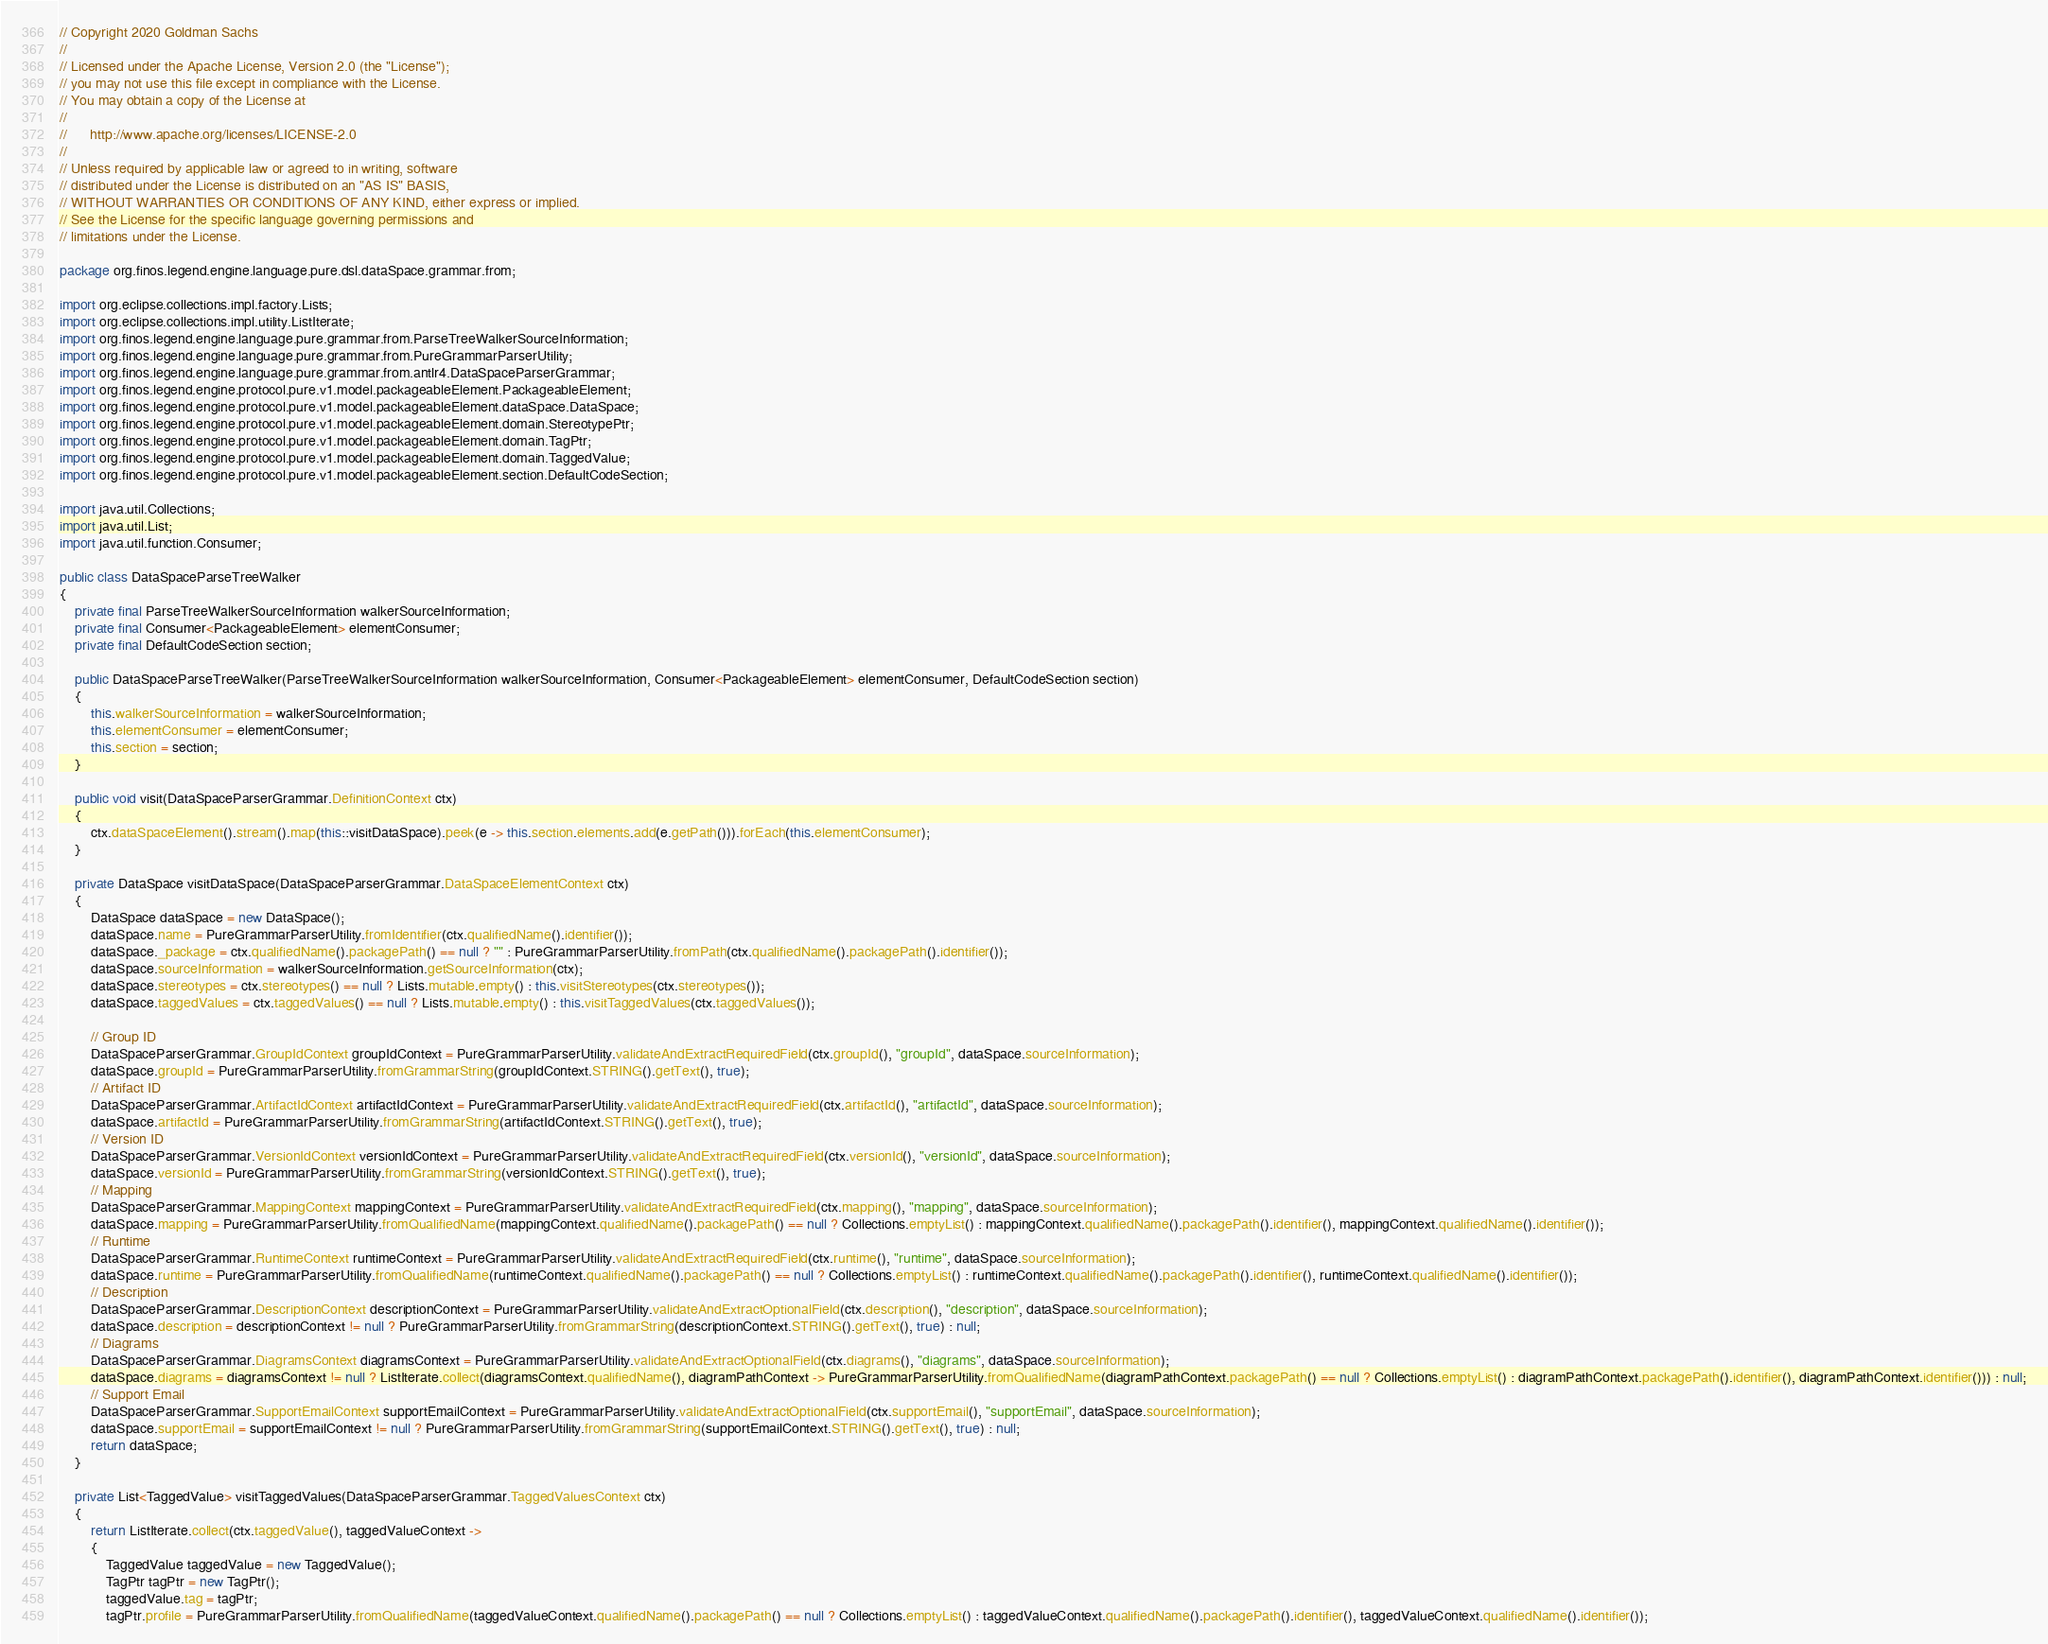Convert code to text. <code><loc_0><loc_0><loc_500><loc_500><_Java_>// Copyright 2020 Goldman Sachs
//
// Licensed under the Apache License, Version 2.0 (the "License");
// you may not use this file except in compliance with the License.
// You may obtain a copy of the License at
//
//      http://www.apache.org/licenses/LICENSE-2.0
//
// Unless required by applicable law or agreed to in writing, software
// distributed under the License is distributed on an "AS IS" BASIS,
// WITHOUT WARRANTIES OR CONDITIONS OF ANY KIND, either express or implied.
// See the License for the specific language governing permissions and
// limitations under the License.

package org.finos.legend.engine.language.pure.dsl.dataSpace.grammar.from;

import org.eclipse.collections.impl.factory.Lists;
import org.eclipse.collections.impl.utility.ListIterate;
import org.finos.legend.engine.language.pure.grammar.from.ParseTreeWalkerSourceInformation;
import org.finos.legend.engine.language.pure.grammar.from.PureGrammarParserUtility;
import org.finos.legend.engine.language.pure.grammar.from.antlr4.DataSpaceParserGrammar;
import org.finos.legend.engine.protocol.pure.v1.model.packageableElement.PackageableElement;
import org.finos.legend.engine.protocol.pure.v1.model.packageableElement.dataSpace.DataSpace;
import org.finos.legend.engine.protocol.pure.v1.model.packageableElement.domain.StereotypePtr;
import org.finos.legend.engine.protocol.pure.v1.model.packageableElement.domain.TagPtr;
import org.finos.legend.engine.protocol.pure.v1.model.packageableElement.domain.TaggedValue;
import org.finos.legend.engine.protocol.pure.v1.model.packageableElement.section.DefaultCodeSection;

import java.util.Collections;
import java.util.List;
import java.util.function.Consumer;

public class DataSpaceParseTreeWalker
{
    private final ParseTreeWalkerSourceInformation walkerSourceInformation;
    private final Consumer<PackageableElement> elementConsumer;
    private final DefaultCodeSection section;

    public DataSpaceParseTreeWalker(ParseTreeWalkerSourceInformation walkerSourceInformation, Consumer<PackageableElement> elementConsumer, DefaultCodeSection section)
    {
        this.walkerSourceInformation = walkerSourceInformation;
        this.elementConsumer = elementConsumer;
        this.section = section;
    }

    public void visit(DataSpaceParserGrammar.DefinitionContext ctx)
    {
        ctx.dataSpaceElement().stream().map(this::visitDataSpace).peek(e -> this.section.elements.add(e.getPath())).forEach(this.elementConsumer);
    }

    private DataSpace visitDataSpace(DataSpaceParserGrammar.DataSpaceElementContext ctx)
    {
        DataSpace dataSpace = new DataSpace();
        dataSpace.name = PureGrammarParserUtility.fromIdentifier(ctx.qualifiedName().identifier());
        dataSpace._package = ctx.qualifiedName().packagePath() == null ? "" : PureGrammarParserUtility.fromPath(ctx.qualifiedName().packagePath().identifier());
        dataSpace.sourceInformation = walkerSourceInformation.getSourceInformation(ctx);
        dataSpace.stereotypes = ctx.stereotypes() == null ? Lists.mutable.empty() : this.visitStereotypes(ctx.stereotypes());
        dataSpace.taggedValues = ctx.taggedValues() == null ? Lists.mutable.empty() : this.visitTaggedValues(ctx.taggedValues());

        // Group ID
        DataSpaceParserGrammar.GroupIdContext groupIdContext = PureGrammarParserUtility.validateAndExtractRequiredField(ctx.groupId(), "groupId", dataSpace.sourceInformation);
        dataSpace.groupId = PureGrammarParserUtility.fromGrammarString(groupIdContext.STRING().getText(), true);
        // Artifact ID
        DataSpaceParserGrammar.ArtifactIdContext artifactIdContext = PureGrammarParserUtility.validateAndExtractRequiredField(ctx.artifactId(), "artifactId", dataSpace.sourceInformation);
        dataSpace.artifactId = PureGrammarParserUtility.fromGrammarString(artifactIdContext.STRING().getText(), true);
        // Version ID
        DataSpaceParserGrammar.VersionIdContext versionIdContext = PureGrammarParserUtility.validateAndExtractRequiredField(ctx.versionId(), "versionId", dataSpace.sourceInformation);
        dataSpace.versionId = PureGrammarParserUtility.fromGrammarString(versionIdContext.STRING().getText(), true);
        // Mapping
        DataSpaceParserGrammar.MappingContext mappingContext = PureGrammarParserUtility.validateAndExtractRequiredField(ctx.mapping(), "mapping", dataSpace.sourceInformation);
        dataSpace.mapping = PureGrammarParserUtility.fromQualifiedName(mappingContext.qualifiedName().packagePath() == null ? Collections.emptyList() : mappingContext.qualifiedName().packagePath().identifier(), mappingContext.qualifiedName().identifier());
        // Runtime
        DataSpaceParserGrammar.RuntimeContext runtimeContext = PureGrammarParserUtility.validateAndExtractRequiredField(ctx.runtime(), "runtime", dataSpace.sourceInformation);
        dataSpace.runtime = PureGrammarParserUtility.fromQualifiedName(runtimeContext.qualifiedName().packagePath() == null ? Collections.emptyList() : runtimeContext.qualifiedName().packagePath().identifier(), runtimeContext.qualifiedName().identifier());
        // Description
        DataSpaceParserGrammar.DescriptionContext descriptionContext = PureGrammarParserUtility.validateAndExtractOptionalField(ctx.description(), "description", dataSpace.sourceInformation);
        dataSpace.description = descriptionContext != null ? PureGrammarParserUtility.fromGrammarString(descriptionContext.STRING().getText(), true) : null;
        // Diagrams
        DataSpaceParserGrammar.DiagramsContext diagramsContext = PureGrammarParserUtility.validateAndExtractOptionalField(ctx.diagrams(), "diagrams", dataSpace.sourceInformation);
        dataSpace.diagrams = diagramsContext != null ? ListIterate.collect(diagramsContext.qualifiedName(), diagramPathContext -> PureGrammarParserUtility.fromQualifiedName(diagramPathContext.packagePath() == null ? Collections.emptyList() : diagramPathContext.packagePath().identifier(), diagramPathContext.identifier())) : null;
        // Support Email
        DataSpaceParserGrammar.SupportEmailContext supportEmailContext = PureGrammarParserUtility.validateAndExtractOptionalField(ctx.supportEmail(), "supportEmail", dataSpace.sourceInformation);
        dataSpace.supportEmail = supportEmailContext != null ? PureGrammarParserUtility.fromGrammarString(supportEmailContext.STRING().getText(), true) : null;
        return dataSpace;
    }

    private List<TaggedValue> visitTaggedValues(DataSpaceParserGrammar.TaggedValuesContext ctx)
    {
        return ListIterate.collect(ctx.taggedValue(), taggedValueContext ->
        {
            TaggedValue taggedValue = new TaggedValue();
            TagPtr tagPtr = new TagPtr();
            taggedValue.tag = tagPtr;
            tagPtr.profile = PureGrammarParserUtility.fromQualifiedName(taggedValueContext.qualifiedName().packagePath() == null ? Collections.emptyList() : taggedValueContext.qualifiedName().packagePath().identifier(), taggedValueContext.qualifiedName().identifier());</code> 